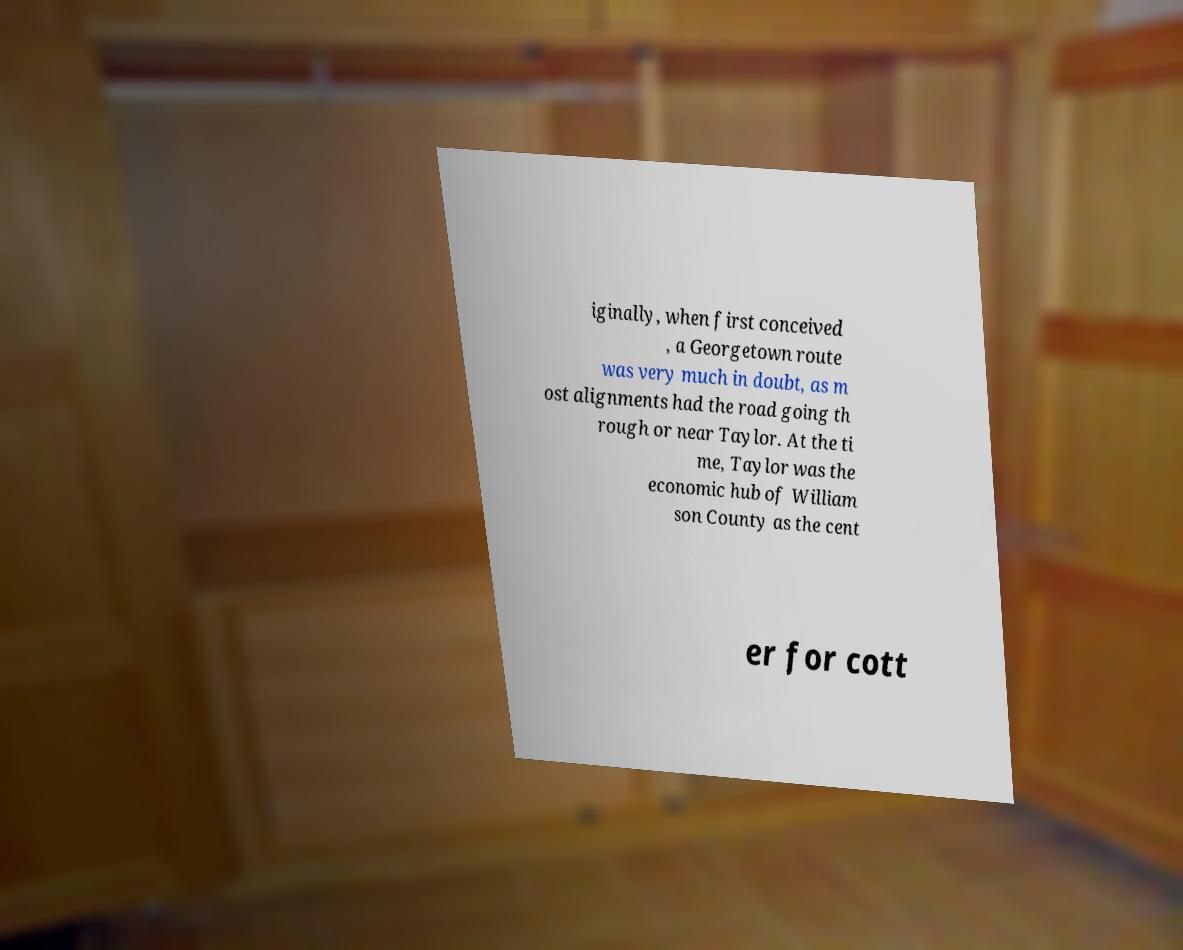Can you accurately transcribe the text from the provided image for me? iginally, when first conceived , a Georgetown route was very much in doubt, as m ost alignments had the road going th rough or near Taylor. At the ti me, Taylor was the economic hub of William son County as the cent er for cott 